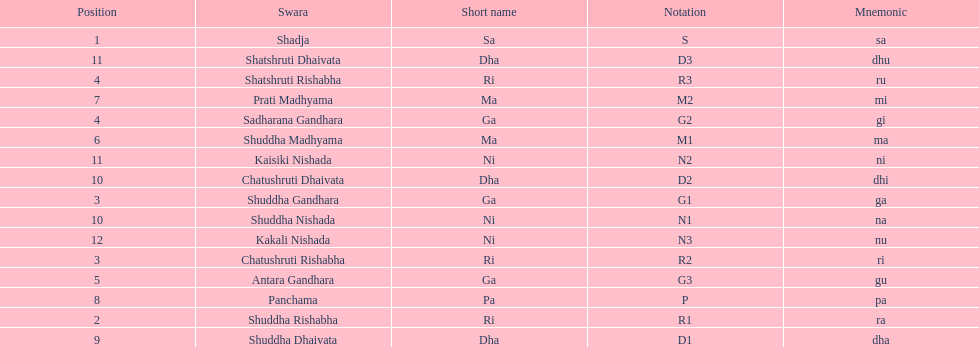What is the name of the swara that comes after panchama? Shuddha Dhaivata. 